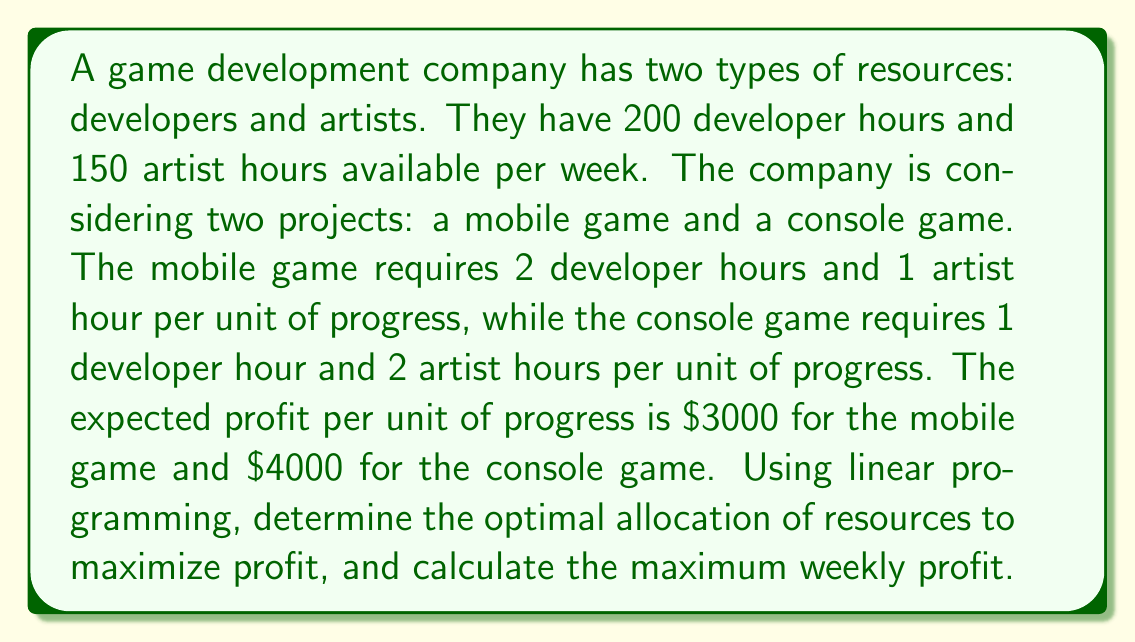Solve this math problem. Let's approach this step-by-step using linear programming:

1. Define variables:
   Let $x$ = units of progress on the mobile game
   Let $y$ = units of progress on the console game

2. Set up the objective function (maximize profit):
   $$\text{Maximize } Z = 3000x + 4000y$$

3. Identify constraints:
   Developer hours: $2x + y \leq 200$
   Artist hours: $x + 2y \leq 150$
   Non-negativity: $x \geq 0, y \geq 0$

4. Graph the constraints:
   [asy]
   import graph;
   size(200);
   xaxis("x", 0, 100);
   yaxis("y", 0, 100);
   draw((0,75)--(100,25), blue);
   draw((0,100)--(100,0), red);
   label("2x + y = 200", (80,20), blue);
   label("x + 2y = 150", (20,60), red);
   fill((0,0)--(0,75)--(60,30)--(100,0)--cycle, palegreen);
   [/asy]

5. Identify corner points:
   (0,0), (0,75), (60,30), (100,0)

6. Evaluate the objective function at each corner point:
   (0,0): $Z = 0$
   (0,75): $Z = 300,000$
   (60,30): $Z = 300,000$
   (100,0): $Z = 300,000$

7. The optimal solution occurs at (60,30), where both constraints intersect.

8. Calculate the maximum profit:
   $Z = 3000(60) + 4000(30) = 180,000 + 120,000 = 300,000$

Therefore, the optimal allocation is to produce 60 units of progress on the mobile game and 30 units of progress on the console game, resulting in a maximum weekly profit of $300,000.
Answer: 60 units mobile, 30 units console; $300,000 weekly profit 